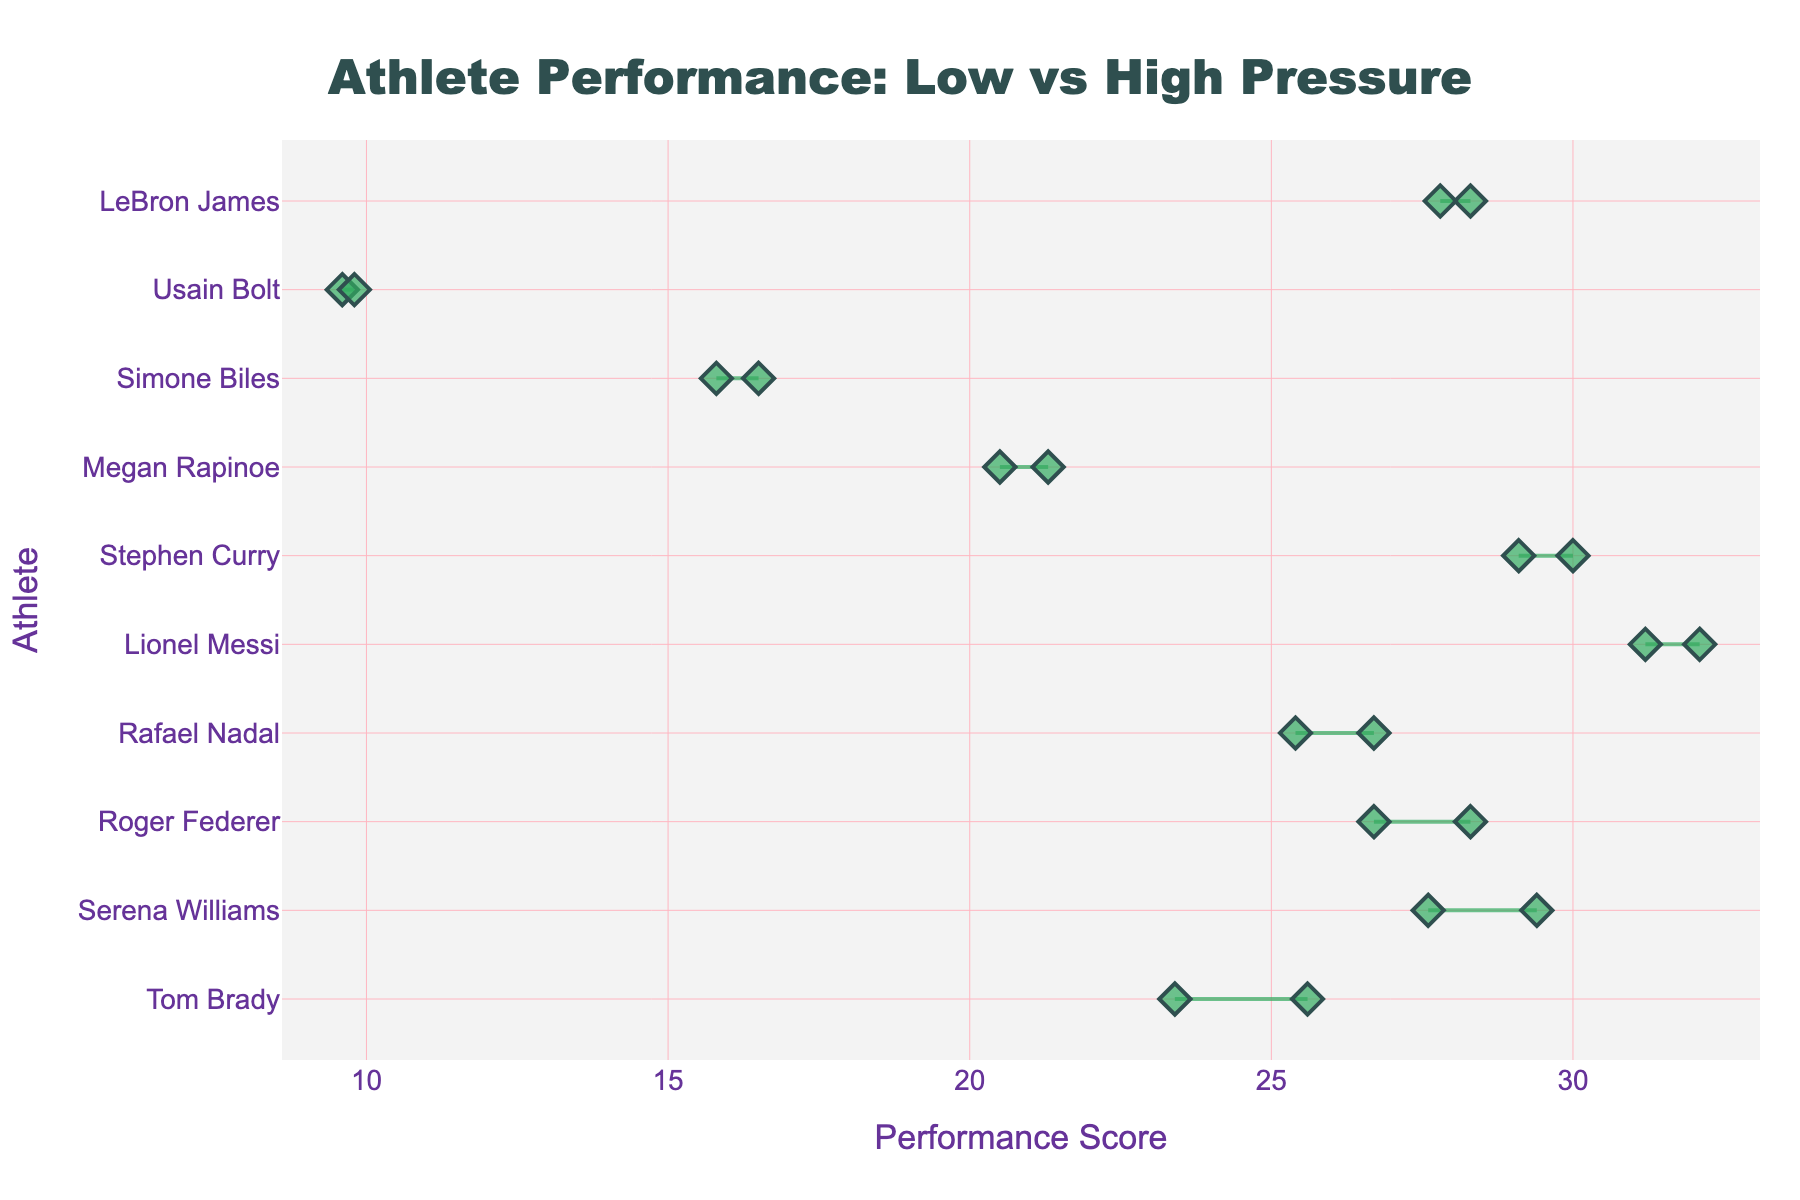What's the title of the chart? The title can be seen at the top center of the chart and typically summarizes what the chart is depicting in concise terms.
Answer: Athlete Performance: Low vs High Pressure Which athlete has the highest performance under high-pressure conditions? To identify this, look at the values on the x-axis and the markers for high-pressure conditions. The highest value corresponds to Lionel Messi with a performance score of 32.1.
Answer: Lionel Messi How many athletes have a better performance under high-pressure than low-pressure conditions? Count the number of athletes where the performance score increases from low-pressure to high-pressure conditions.
Answer: 10 What is the average increase in performance from low to high pressure across all athletes? Calculate the difference between high-pressure and low-pressure performance for each athlete, sum these differences, and then divide by the number of athletes. The sum of differences is (0.5 + 2.2 + 0.9 + 1.8 + 1.6 + 0.9 + 0.7 + 0.2 + 0.8 + 1.3) = 10.9, divided by 10 athletes, so the average increase is 1.09.
Answer: 1.09 Which athlete has the largest increase in performance when moving from low-pressure to high-pressure conditions? Compare the difference between low and high pressure for each athlete to find the largest increase. Tom Brady has the largest increase with a difference of 2.2 (25.6 - 23.4).
Answer: Tom Brady Who performs roughly the same under both conditions? Look for the athlete with the smallest difference between low and high-pressure performance. This is Usain Bolt with a difference of 0.2 (9.8 - 9.6).
Answer: Usain Bolt How does Serena Williams’ performance change from low to high pressure? Refer to Serena Williams' low-pressure and high-pressure values on the x-axis. Serena Williams’ performance changes from 27.6 to 29.4, so the change is 29.4 - 27.6 = 1.8.
Answer: Increases by 1.8 Which athlete has the smallest performance difference between low and high-pressure scenarios, and what is that difference? The smallest difference can be identified by examining the performance changes. Usain Bolt shows the smallest difference of 0.2 (9.8 - 9.6).
Answer: Usain Bolt, 0.2 Who has the highest low-pressure performance? Identify the highest value on the x-axis under low-pressure conditions. Lionel Messi has the highest low-pressure performance value of 31.2.
Answer: Lionel Messi 